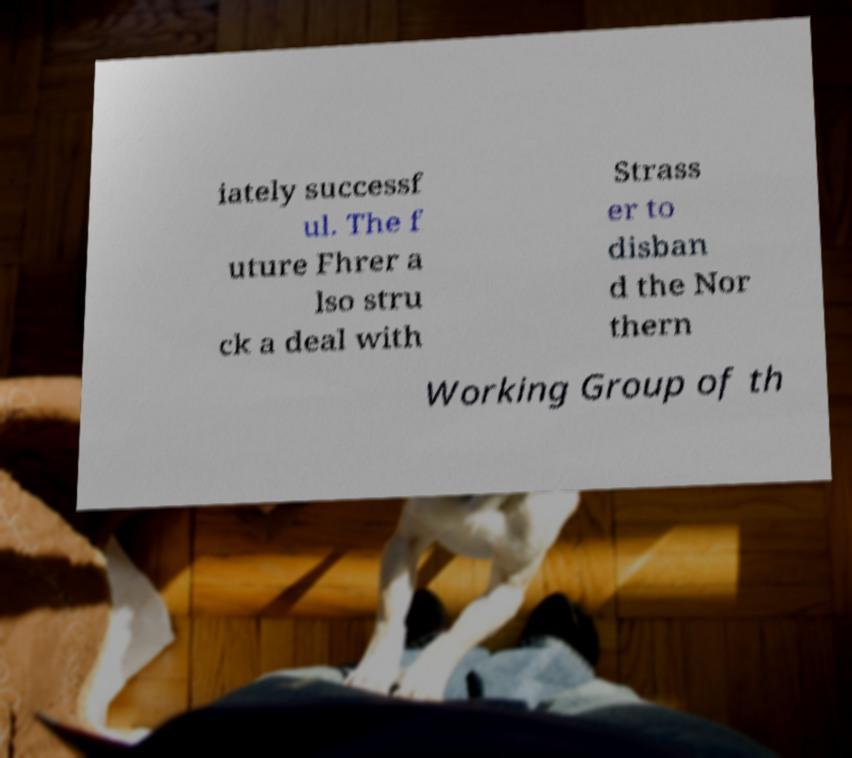Please read and relay the text visible in this image. What does it say? iately successf ul. The f uture Fhrer a lso stru ck a deal with Strass er to disban d the Nor thern Working Group of th 